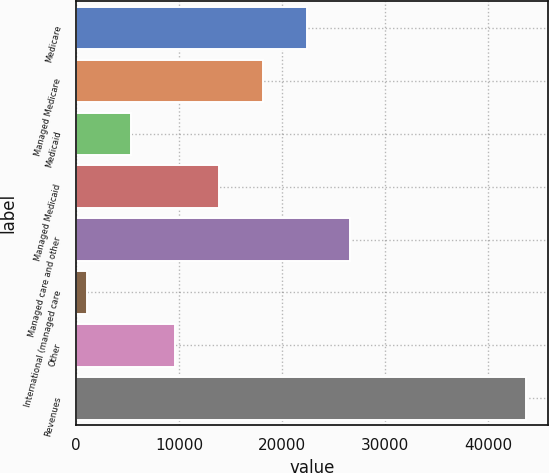Convert chart to OTSL. <chart><loc_0><loc_0><loc_500><loc_500><bar_chart><fcel>Medicare<fcel>Managed Medicare<fcel>Medicaid<fcel>Managed Medicaid<fcel>Managed care and other<fcel>International (managed care<fcel>Other<fcel>Revenues<nl><fcel>22355.5<fcel>18103.8<fcel>5348.7<fcel>13852.1<fcel>26607.2<fcel>1097<fcel>9600.4<fcel>43614<nl></chart> 